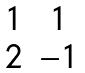<formula> <loc_0><loc_0><loc_500><loc_500>\begin{matrix} 1 & 1 \\ 2 & - 1 \end{matrix}</formula> 